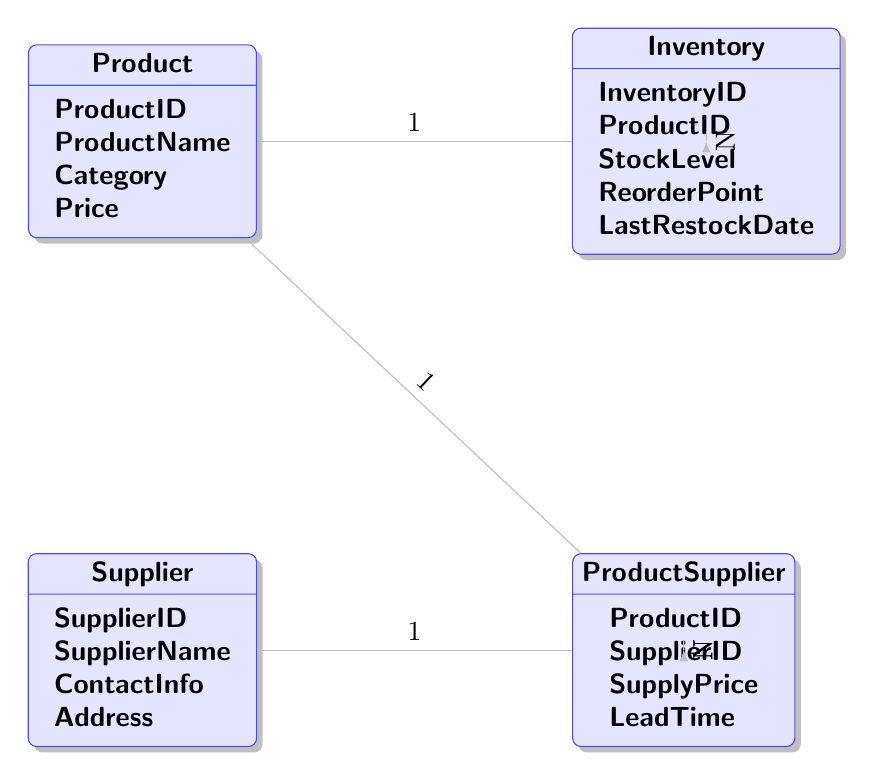What is the primary key of the Product entity? The primary key for the Product entity is indicated by the "key" attribute in the diagram, which is "ProductID".
Answer: ProductID How many attributes does the Supplier entity have? The Supplier entity has four attributes listed in the diagram: SupplierID, SupplierName, ContactInfo, Address. Therefore, the total count is four.
Answer: 4 What is the relationship type between Product and Inventory? The relationship type between Product and Inventory is labeled as "one_to_many", which means one product can have multiple inventory records.
Answer: one_to_many How many foreign keys does the ProductSupplier entity have? The ProductSupplier entity has two foreign keys, which reference ProductID from Product and SupplierID from Supplier, as shown in the foreign_keys section of the diagram.
Answer: 2 Which entity can be represented as having a direct connection to both Inventories and ProductSupplier? The Product entity connects directly to both Inventory and ProductSupplier entities, as indicated by the direct lines drawn in the diagram from Product to these entities.
Answer: Product What is the relationship between Supplier and ProductSupplier? The relationship between Supplier and ProductSupplier is also "one_to_many", indicating that one supplier can supply multiple products as represented in the diagram.
Answer: one_to_many What does the ReorderPoint attribute in the Inventory entity represent? The ReorderPoint attribute indicates the stock level at which a product needs to be reordered, ensuring optimal stock levels are maintained.
Answer: Stock level for reordering Which entity contains the attribute SupplyPrice? The attribute SupplyPrice is found solely within the ProductSupplier entity, as listed in its attributes in the diagram.
Answer: ProductSupplier What is the last attribute listed for the Inventory entity? The last attribute listed for the Inventory entity is LastRestockDate, as shown in the diagram's attribute section for Inventory.
Answer: LastRestockDate 